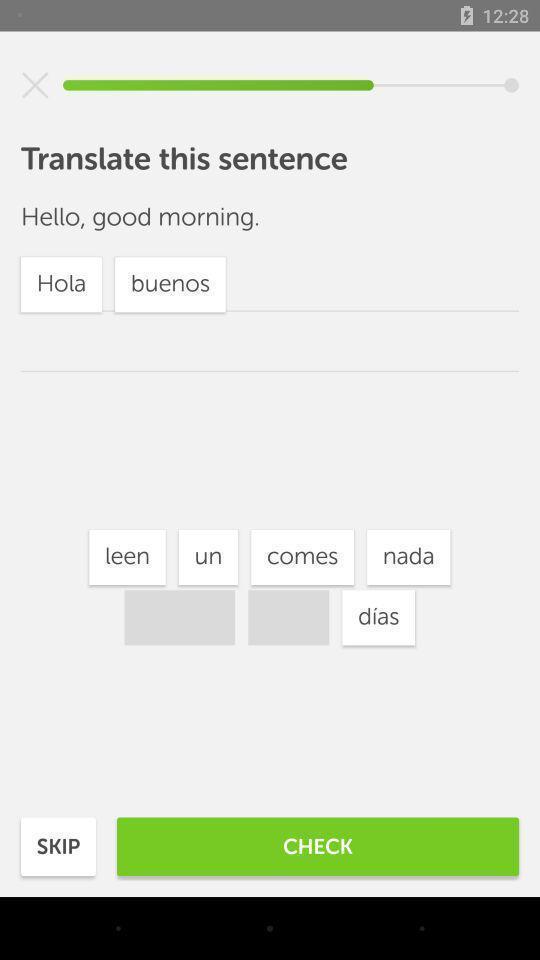Tell me what you see in this picture. Screen displaying page of an translator application. 